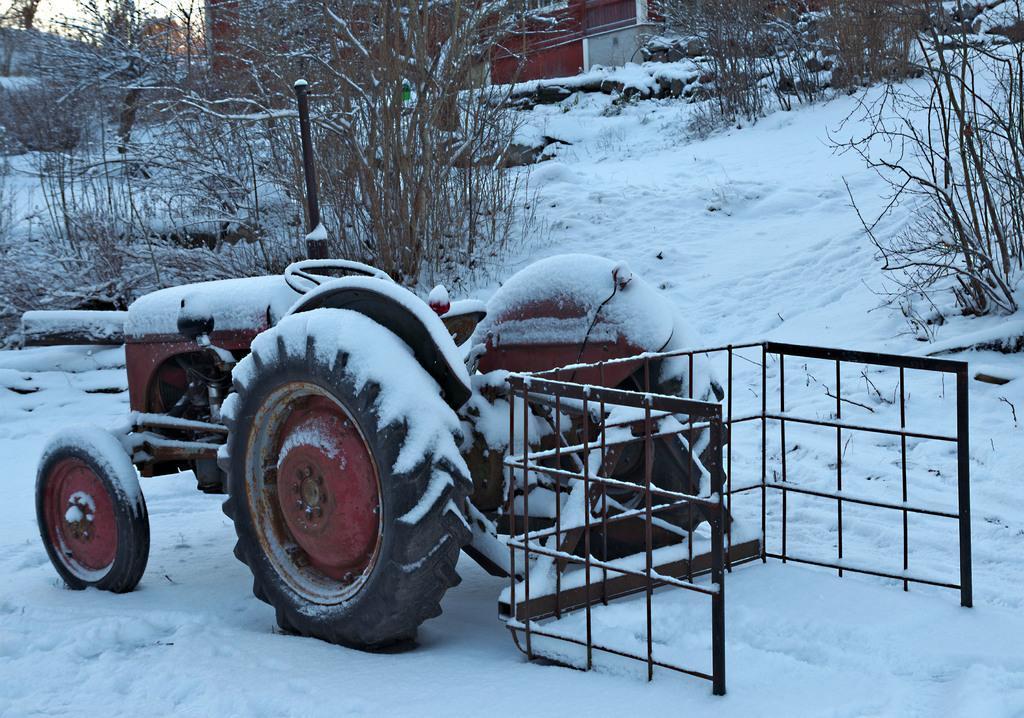Can you describe this image briefly? In this image in the front there is vehicle with a metal object attached to it and on the top of the vehicle there is snow. In the background there are dry trees and there is a house and there is snow on the ground. 